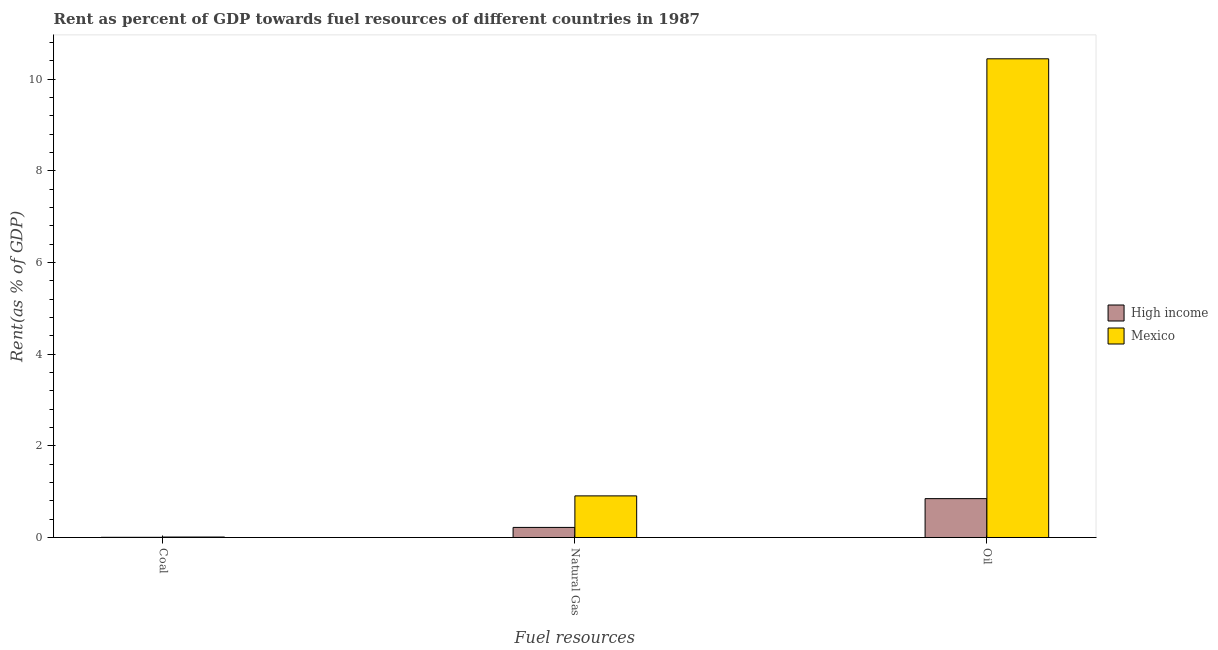How many different coloured bars are there?
Offer a very short reply. 2. How many groups of bars are there?
Ensure brevity in your answer.  3. Are the number of bars on each tick of the X-axis equal?
Ensure brevity in your answer.  Yes. What is the label of the 2nd group of bars from the left?
Make the answer very short. Natural Gas. What is the rent towards natural gas in High income?
Offer a very short reply. 0.22. Across all countries, what is the maximum rent towards coal?
Make the answer very short. 0.01. Across all countries, what is the minimum rent towards oil?
Provide a succinct answer. 0.85. In which country was the rent towards natural gas maximum?
Your response must be concise. Mexico. In which country was the rent towards coal minimum?
Offer a very short reply. High income. What is the total rent towards oil in the graph?
Your answer should be very brief. 11.29. What is the difference between the rent towards oil in Mexico and that in High income?
Provide a succinct answer. 9.6. What is the difference between the rent towards oil in Mexico and the rent towards natural gas in High income?
Provide a succinct answer. 10.23. What is the average rent towards natural gas per country?
Your response must be concise. 0.56. What is the difference between the rent towards natural gas and rent towards oil in High income?
Your answer should be compact. -0.63. What is the ratio of the rent towards natural gas in High income to that in Mexico?
Make the answer very short. 0.24. Is the rent towards natural gas in Mexico less than that in High income?
Make the answer very short. No. Is the difference between the rent towards natural gas in Mexico and High income greater than the difference between the rent towards oil in Mexico and High income?
Provide a short and direct response. No. What is the difference between the highest and the second highest rent towards natural gas?
Your answer should be compact. 0.69. What is the difference between the highest and the lowest rent towards natural gas?
Give a very brief answer. 0.69. In how many countries, is the rent towards natural gas greater than the average rent towards natural gas taken over all countries?
Offer a terse response. 1. Is the sum of the rent towards oil in High income and Mexico greater than the maximum rent towards natural gas across all countries?
Offer a terse response. Yes. What does the 1st bar from the left in Natural Gas represents?
Ensure brevity in your answer.  High income. What does the 2nd bar from the right in Oil represents?
Offer a terse response. High income. Is it the case that in every country, the sum of the rent towards coal and rent towards natural gas is greater than the rent towards oil?
Keep it short and to the point. No. How many bars are there?
Make the answer very short. 6. Are all the bars in the graph horizontal?
Your answer should be very brief. No. What is the difference between two consecutive major ticks on the Y-axis?
Your answer should be compact. 2. Where does the legend appear in the graph?
Make the answer very short. Center right. How many legend labels are there?
Give a very brief answer. 2. How are the legend labels stacked?
Make the answer very short. Vertical. What is the title of the graph?
Your answer should be very brief. Rent as percent of GDP towards fuel resources of different countries in 1987. What is the label or title of the X-axis?
Your answer should be compact. Fuel resources. What is the label or title of the Y-axis?
Make the answer very short. Rent(as % of GDP). What is the Rent(as % of GDP) in High income in Coal?
Keep it short and to the point. 0. What is the Rent(as % of GDP) of Mexico in Coal?
Provide a short and direct response. 0.01. What is the Rent(as % of GDP) of High income in Natural Gas?
Offer a very short reply. 0.22. What is the Rent(as % of GDP) in Mexico in Natural Gas?
Provide a succinct answer. 0.91. What is the Rent(as % of GDP) in High income in Oil?
Offer a very short reply. 0.85. What is the Rent(as % of GDP) of Mexico in Oil?
Give a very brief answer. 10.45. Across all Fuel resources, what is the maximum Rent(as % of GDP) of High income?
Your answer should be compact. 0.85. Across all Fuel resources, what is the maximum Rent(as % of GDP) of Mexico?
Ensure brevity in your answer.  10.45. Across all Fuel resources, what is the minimum Rent(as % of GDP) of High income?
Keep it short and to the point. 0. Across all Fuel resources, what is the minimum Rent(as % of GDP) in Mexico?
Give a very brief answer. 0.01. What is the total Rent(as % of GDP) of High income in the graph?
Your response must be concise. 1.07. What is the total Rent(as % of GDP) of Mexico in the graph?
Provide a succinct answer. 11.36. What is the difference between the Rent(as % of GDP) in High income in Coal and that in Natural Gas?
Your response must be concise. -0.22. What is the difference between the Rent(as % of GDP) in Mexico in Coal and that in Natural Gas?
Give a very brief answer. -0.9. What is the difference between the Rent(as % of GDP) of High income in Coal and that in Oil?
Your answer should be very brief. -0.84. What is the difference between the Rent(as % of GDP) of Mexico in Coal and that in Oil?
Provide a succinct answer. -10.44. What is the difference between the Rent(as % of GDP) in High income in Natural Gas and that in Oil?
Your response must be concise. -0.63. What is the difference between the Rent(as % of GDP) of Mexico in Natural Gas and that in Oil?
Offer a very short reply. -9.54. What is the difference between the Rent(as % of GDP) in High income in Coal and the Rent(as % of GDP) in Mexico in Natural Gas?
Give a very brief answer. -0.9. What is the difference between the Rent(as % of GDP) in High income in Coal and the Rent(as % of GDP) in Mexico in Oil?
Keep it short and to the point. -10.44. What is the difference between the Rent(as % of GDP) in High income in Natural Gas and the Rent(as % of GDP) in Mexico in Oil?
Provide a succinct answer. -10.23. What is the average Rent(as % of GDP) in High income per Fuel resources?
Ensure brevity in your answer.  0.36. What is the average Rent(as % of GDP) of Mexico per Fuel resources?
Give a very brief answer. 3.79. What is the difference between the Rent(as % of GDP) in High income and Rent(as % of GDP) in Mexico in Coal?
Your answer should be compact. -0.01. What is the difference between the Rent(as % of GDP) of High income and Rent(as % of GDP) of Mexico in Natural Gas?
Give a very brief answer. -0.69. What is the difference between the Rent(as % of GDP) in High income and Rent(as % of GDP) in Mexico in Oil?
Ensure brevity in your answer.  -9.6. What is the ratio of the Rent(as % of GDP) of High income in Coal to that in Natural Gas?
Give a very brief answer. 0.02. What is the ratio of the Rent(as % of GDP) of Mexico in Coal to that in Natural Gas?
Offer a terse response. 0.01. What is the ratio of the Rent(as % of GDP) in High income in Coal to that in Oil?
Offer a very short reply. 0. What is the ratio of the Rent(as % of GDP) of Mexico in Coal to that in Oil?
Give a very brief answer. 0. What is the ratio of the Rent(as % of GDP) in High income in Natural Gas to that in Oil?
Give a very brief answer. 0.26. What is the ratio of the Rent(as % of GDP) in Mexico in Natural Gas to that in Oil?
Give a very brief answer. 0.09. What is the difference between the highest and the second highest Rent(as % of GDP) of High income?
Make the answer very short. 0.63. What is the difference between the highest and the second highest Rent(as % of GDP) of Mexico?
Provide a short and direct response. 9.54. What is the difference between the highest and the lowest Rent(as % of GDP) in High income?
Your response must be concise. 0.84. What is the difference between the highest and the lowest Rent(as % of GDP) in Mexico?
Keep it short and to the point. 10.44. 